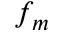<formula> <loc_0><loc_0><loc_500><loc_500>f _ { m }</formula> 